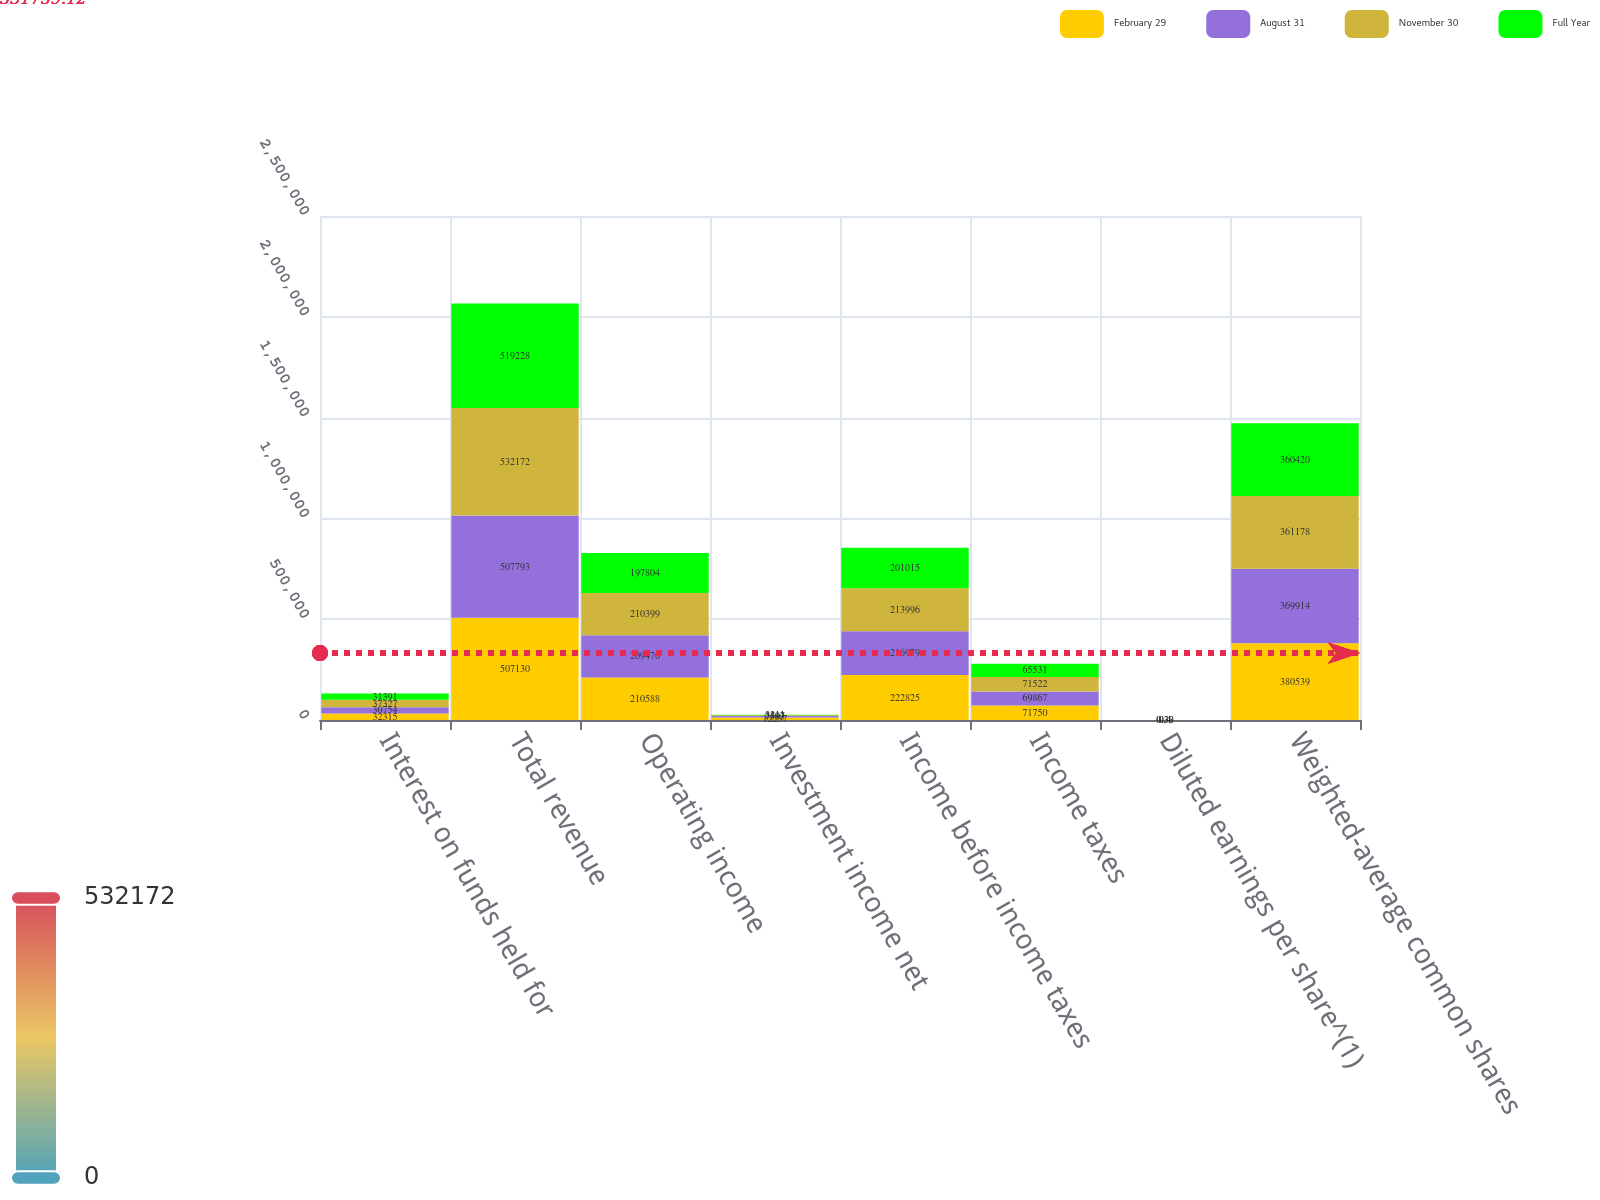<chart> <loc_0><loc_0><loc_500><loc_500><stacked_bar_chart><ecel><fcel>Interest on funds held for<fcel>Total revenue<fcel>Operating income<fcel>Investment income net<fcel>Income before income taxes<fcel>Income taxes<fcel>Diluted earnings per share^(1)<fcel>Weighted-average common shares<nl><fcel>February 29<fcel>32315<fcel>507130<fcel>210588<fcel>12237<fcel>222825<fcel>71750<fcel>0.4<fcel>380539<nl><fcel>August 31<fcel>30754<fcel>507793<fcel>209476<fcel>7503<fcel>216979<fcel>69867<fcel>0.4<fcel>369914<nl><fcel>November 30<fcel>37327<fcel>532172<fcel>210399<fcel>3597<fcel>213996<fcel>71522<fcel>0.39<fcel>361178<nl><fcel>Full Year<fcel>31391<fcel>519228<fcel>197804<fcel>3211<fcel>201015<fcel>65531<fcel>0.38<fcel>360420<nl></chart> 